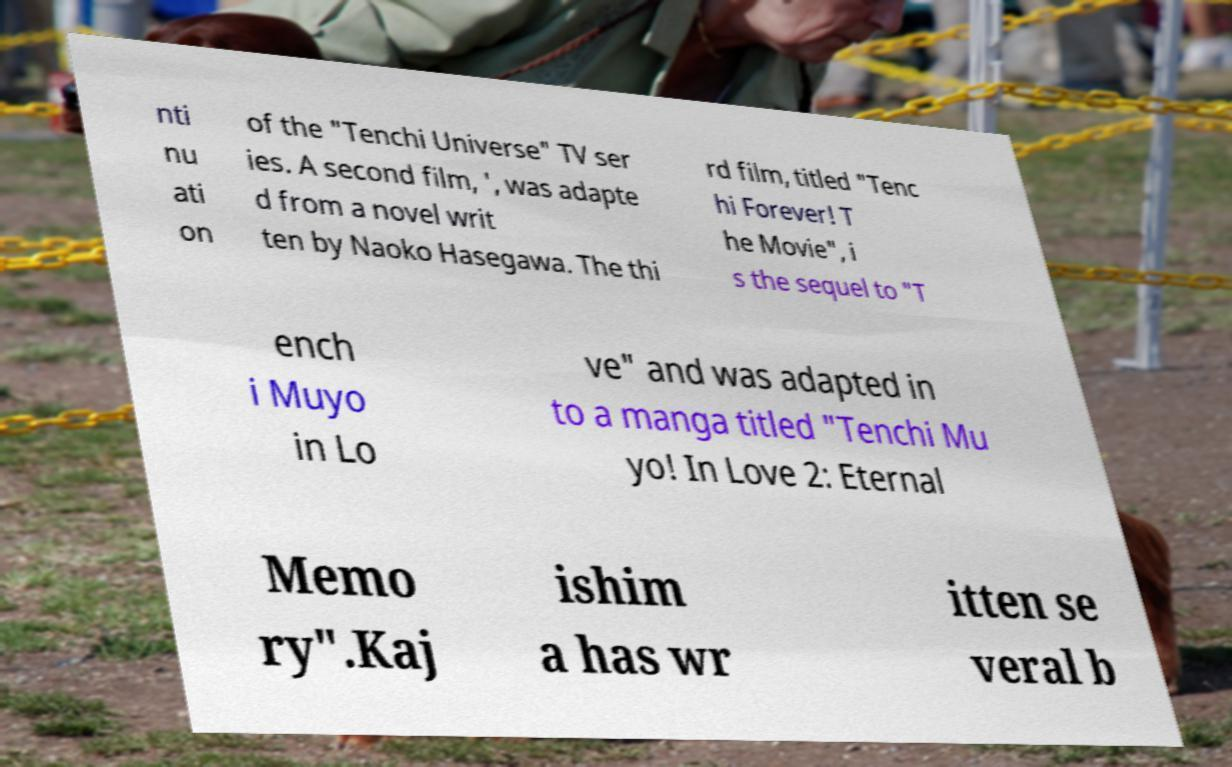Can you read and provide the text displayed in the image?This photo seems to have some interesting text. Can you extract and type it out for me? nti nu ati on of the "Tenchi Universe" TV ser ies. A second film, ', was adapte d from a novel writ ten by Naoko Hasegawa. The thi rd film, titled "Tenc hi Forever! T he Movie", i s the sequel to "T ench i Muyo in Lo ve" and was adapted in to a manga titled "Tenchi Mu yo! In Love 2: Eternal Memo ry".Kaj ishim a has wr itten se veral b 